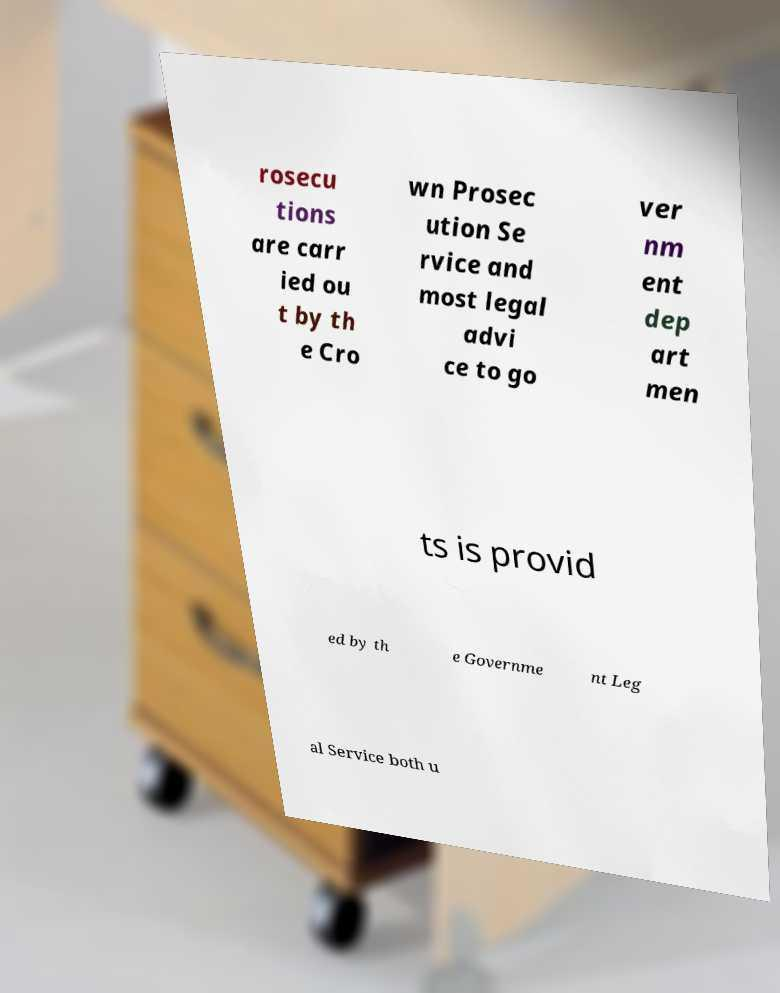Can you read and provide the text displayed in the image?This photo seems to have some interesting text. Can you extract and type it out for me? rosecu tions are carr ied ou t by th e Cro wn Prosec ution Se rvice and most legal advi ce to go ver nm ent dep art men ts is provid ed by th e Governme nt Leg al Service both u 